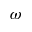Convert formula to latex. <formula><loc_0><loc_0><loc_500><loc_500>\omega</formula> 